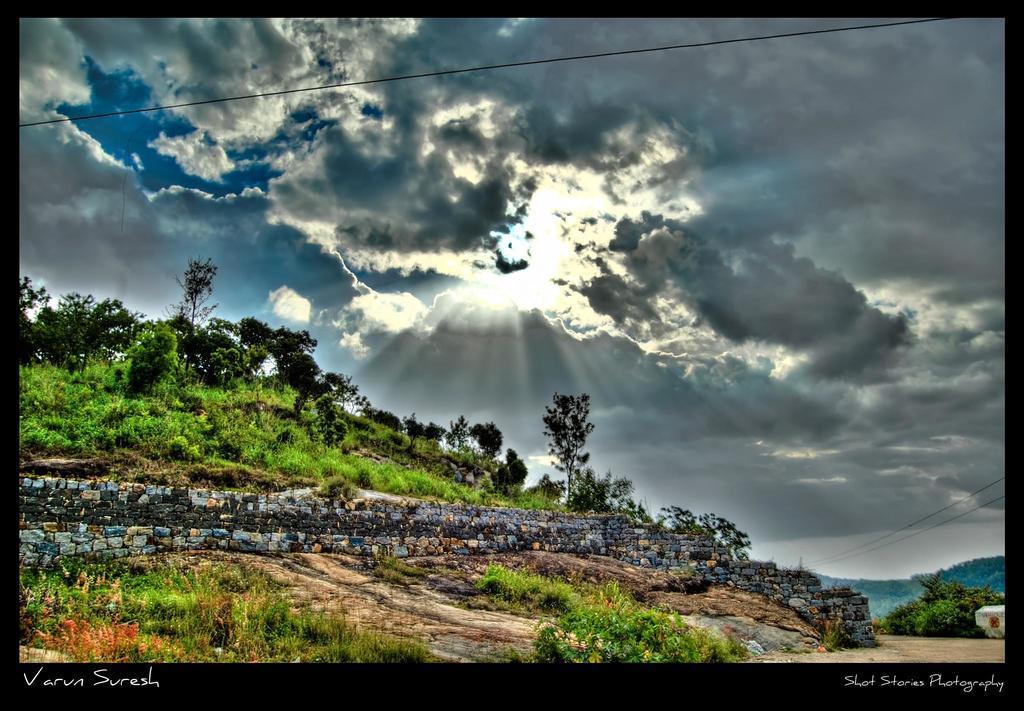Could you give a brief overview of what you see in this image? In this picture I can see trees, plants and I can see blue cloudy sky and I can see text at the bottom left and at the bottom right corners of the picture. 